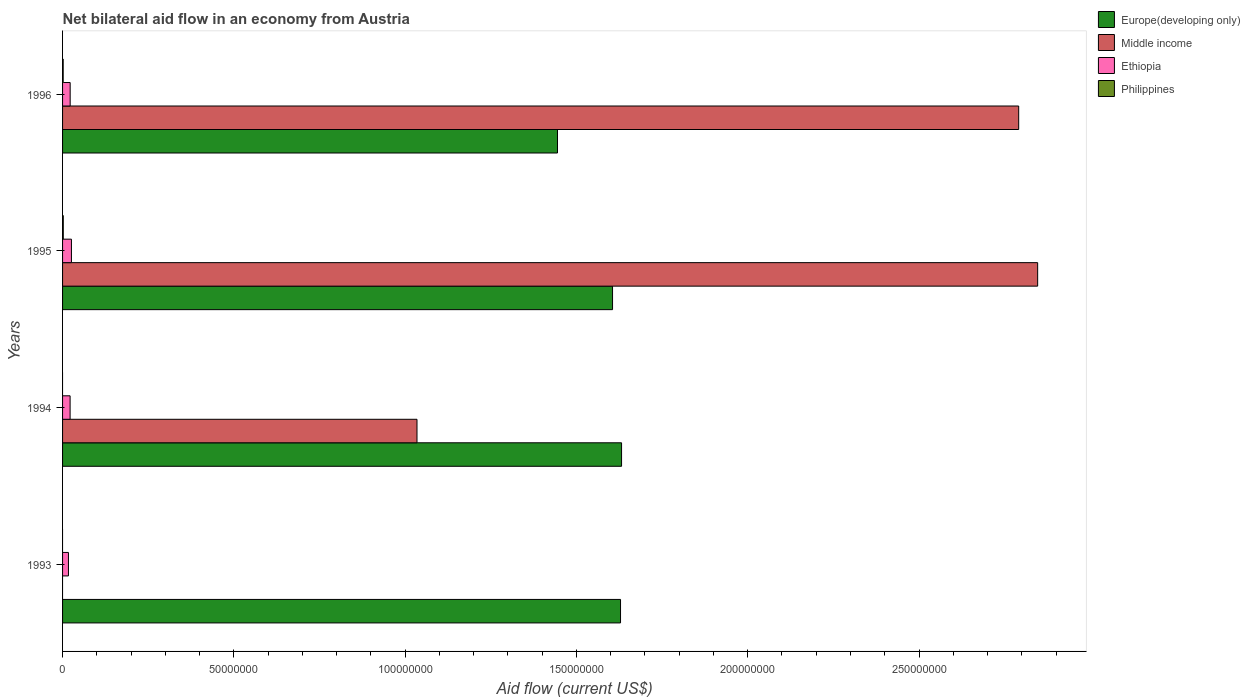How many groups of bars are there?
Make the answer very short. 4. Are the number of bars on each tick of the Y-axis equal?
Offer a terse response. No. How many bars are there on the 1st tick from the top?
Keep it short and to the point. 4. What is the label of the 4th group of bars from the top?
Your answer should be compact. 1993. In how many cases, is the number of bars for a given year not equal to the number of legend labels?
Offer a very short reply. 2. What is the net bilateral aid flow in Philippines in 1993?
Your response must be concise. 0. Across all years, what is the maximum net bilateral aid flow in Ethiopia?
Give a very brief answer. 2.59e+06. Across all years, what is the minimum net bilateral aid flow in Ethiopia?
Provide a short and direct response. 1.72e+06. What is the total net bilateral aid flow in Ethiopia in the graph?
Provide a short and direct response. 8.73e+06. What is the difference between the net bilateral aid flow in Ethiopia in 1993 and that in 1995?
Offer a very short reply. -8.70e+05. What is the difference between the net bilateral aid flow in Europe(developing only) in 1993 and the net bilateral aid flow in Ethiopia in 1995?
Provide a short and direct response. 1.60e+08. What is the average net bilateral aid flow in Middle income per year?
Provide a succinct answer. 1.67e+08. In the year 1996, what is the difference between the net bilateral aid flow in Europe(developing only) and net bilateral aid flow in Ethiopia?
Keep it short and to the point. 1.42e+08. In how many years, is the net bilateral aid flow in Philippines greater than 10000000 US$?
Make the answer very short. 0. What is the ratio of the net bilateral aid flow in Middle income in 1995 to that in 1996?
Give a very brief answer. 1.02. Is the net bilateral aid flow in Europe(developing only) in 1994 less than that in 1995?
Make the answer very short. No. What is the difference between the highest and the lowest net bilateral aid flow in Europe(developing only)?
Provide a short and direct response. 1.87e+07. Is the sum of the net bilateral aid flow in Europe(developing only) in 1994 and 1996 greater than the maximum net bilateral aid flow in Ethiopia across all years?
Give a very brief answer. Yes. Is it the case that in every year, the sum of the net bilateral aid flow in Middle income and net bilateral aid flow in Ethiopia is greater than the sum of net bilateral aid flow in Philippines and net bilateral aid flow in Europe(developing only)?
Your answer should be very brief. No. Is it the case that in every year, the sum of the net bilateral aid flow in Ethiopia and net bilateral aid flow in Europe(developing only) is greater than the net bilateral aid flow in Middle income?
Your response must be concise. No. How many bars are there?
Your answer should be compact. 13. Are all the bars in the graph horizontal?
Keep it short and to the point. Yes. How many years are there in the graph?
Offer a terse response. 4. Does the graph contain grids?
Keep it short and to the point. No. How are the legend labels stacked?
Provide a short and direct response. Vertical. What is the title of the graph?
Make the answer very short. Net bilateral aid flow in an economy from Austria. Does "Serbia" appear as one of the legend labels in the graph?
Provide a succinct answer. No. What is the Aid flow (current US$) of Europe(developing only) in 1993?
Your answer should be compact. 1.63e+08. What is the Aid flow (current US$) of Middle income in 1993?
Your response must be concise. 0. What is the Aid flow (current US$) in Ethiopia in 1993?
Your answer should be compact. 1.72e+06. What is the Aid flow (current US$) of Philippines in 1993?
Offer a terse response. 0. What is the Aid flow (current US$) of Europe(developing only) in 1994?
Ensure brevity in your answer.  1.63e+08. What is the Aid flow (current US$) in Middle income in 1994?
Give a very brief answer. 1.03e+08. What is the Aid flow (current US$) of Ethiopia in 1994?
Give a very brief answer. 2.20e+06. What is the Aid flow (current US$) of Philippines in 1994?
Give a very brief answer. 0. What is the Aid flow (current US$) in Europe(developing only) in 1995?
Provide a short and direct response. 1.61e+08. What is the Aid flow (current US$) of Middle income in 1995?
Make the answer very short. 2.85e+08. What is the Aid flow (current US$) in Ethiopia in 1995?
Your answer should be compact. 2.59e+06. What is the Aid flow (current US$) in Philippines in 1995?
Your answer should be very brief. 2.10e+05. What is the Aid flow (current US$) in Europe(developing only) in 1996?
Provide a short and direct response. 1.44e+08. What is the Aid flow (current US$) of Middle income in 1996?
Give a very brief answer. 2.79e+08. What is the Aid flow (current US$) in Ethiopia in 1996?
Provide a succinct answer. 2.22e+06. What is the Aid flow (current US$) of Philippines in 1996?
Give a very brief answer. 1.80e+05. Across all years, what is the maximum Aid flow (current US$) of Europe(developing only)?
Ensure brevity in your answer.  1.63e+08. Across all years, what is the maximum Aid flow (current US$) of Middle income?
Keep it short and to the point. 2.85e+08. Across all years, what is the maximum Aid flow (current US$) in Ethiopia?
Keep it short and to the point. 2.59e+06. Across all years, what is the minimum Aid flow (current US$) of Europe(developing only)?
Your answer should be compact. 1.44e+08. Across all years, what is the minimum Aid flow (current US$) of Middle income?
Your answer should be very brief. 0. Across all years, what is the minimum Aid flow (current US$) in Ethiopia?
Give a very brief answer. 1.72e+06. What is the total Aid flow (current US$) in Europe(developing only) in the graph?
Offer a very short reply. 6.31e+08. What is the total Aid flow (current US$) in Middle income in the graph?
Your answer should be compact. 6.67e+08. What is the total Aid flow (current US$) of Ethiopia in the graph?
Ensure brevity in your answer.  8.73e+06. What is the total Aid flow (current US$) of Philippines in the graph?
Your answer should be compact. 3.90e+05. What is the difference between the Aid flow (current US$) in Ethiopia in 1993 and that in 1994?
Keep it short and to the point. -4.80e+05. What is the difference between the Aid flow (current US$) of Europe(developing only) in 1993 and that in 1995?
Offer a very short reply. 2.33e+06. What is the difference between the Aid flow (current US$) of Ethiopia in 1993 and that in 1995?
Give a very brief answer. -8.70e+05. What is the difference between the Aid flow (current US$) of Europe(developing only) in 1993 and that in 1996?
Offer a very short reply. 1.84e+07. What is the difference between the Aid flow (current US$) in Ethiopia in 1993 and that in 1996?
Keep it short and to the point. -5.00e+05. What is the difference between the Aid flow (current US$) in Europe(developing only) in 1994 and that in 1995?
Your answer should be compact. 2.63e+06. What is the difference between the Aid flow (current US$) of Middle income in 1994 and that in 1995?
Keep it short and to the point. -1.81e+08. What is the difference between the Aid flow (current US$) in Ethiopia in 1994 and that in 1995?
Offer a terse response. -3.90e+05. What is the difference between the Aid flow (current US$) in Europe(developing only) in 1994 and that in 1996?
Ensure brevity in your answer.  1.87e+07. What is the difference between the Aid flow (current US$) in Middle income in 1994 and that in 1996?
Your response must be concise. -1.76e+08. What is the difference between the Aid flow (current US$) of Ethiopia in 1994 and that in 1996?
Give a very brief answer. -2.00e+04. What is the difference between the Aid flow (current US$) in Europe(developing only) in 1995 and that in 1996?
Your answer should be very brief. 1.61e+07. What is the difference between the Aid flow (current US$) in Middle income in 1995 and that in 1996?
Your answer should be very brief. 5.54e+06. What is the difference between the Aid flow (current US$) of Philippines in 1995 and that in 1996?
Offer a terse response. 3.00e+04. What is the difference between the Aid flow (current US$) of Europe(developing only) in 1993 and the Aid flow (current US$) of Middle income in 1994?
Your answer should be compact. 5.94e+07. What is the difference between the Aid flow (current US$) in Europe(developing only) in 1993 and the Aid flow (current US$) in Ethiopia in 1994?
Give a very brief answer. 1.61e+08. What is the difference between the Aid flow (current US$) of Europe(developing only) in 1993 and the Aid flow (current US$) of Middle income in 1995?
Give a very brief answer. -1.22e+08. What is the difference between the Aid flow (current US$) in Europe(developing only) in 1993 and the Aid flow (current US$) in Ethiopia in 1995?
Your response must be concise. 1.60e+08. What is the difference between the Aid flow (current US$) of Europe(developing only) in 1993 and the Aid flow (current US$) of Philippines in 1995?
Keep it short and to the point. 1.63e+08. What is the difference between the Aid flow (current US$) of Ethiopia in 1993 and the Aid flow (current US$) of Philippines in 1995?
Provide a succinct answer. 1.51e+06. What is the difference between the Aid flow (current US$) of Europe(developing only) in 1993 and the Aid flow (current US$) of Middle income in 1996?
Your answer should be compact. -1.16e+08. What is the difference between the Aid flow (current US$) of Europe(developing only) in 1993 and the Aid flow (current US$) of Ethiopia in 1996?
Provide a succinct answer. 1.61e+08. What is the difference between the Aid flow (current US$) in Europe(developing only) in 1993 and the Aid flow (current US$) in Philippines in 1996?
Provide a succinct answer. 1.63e+08. What is the difference between the Aid flow (current US$) in Ethiopia in 1993 and the Aid flow (current US$) in Philippines in 1996?
Offer a very short reply. 1.54e+06. What is the difference between the Aid flow (current US$) of Europe(developing only) in 1994 and the Aid flow (current US$) of Middle income in 1995?
Keep it short and to the point. -1.21e+08. What is the difference between the Aid flow (current US$) of Europe(developing only) in 1994 and the Aid flow (current US$) of Ethiopia in 1995?
Offer a terse response. 1.61e+08. What is the difference between the Aid flow (current US$) in Europe(developing only) in 1994 and the Aid flow (current US$) in Philippines in 1995?
Offer a very short reply. 1.63e+08. What is the difference between the Aid flow (current US$) of Middle income in 1994 and the Aid flow (current US$) of Ethiopia in 1995?
Offer a very short reply. 1.01e+08. What is the difference between the Aid flow (current US$) in Middle income in 1994 and the Aid flow (current US$) in Philippines in 1995?
Your answer should be very brief. 1.03e+08. What is the difference between the Aid flow (current US$) in Ethiopia in 1994 and the Aid flow (current US$) in Philippines in 1995?
Provide a short and direct response. 1.99e+06. What is the difference between the Aid flow (current US$) of Europe(developing only) in 1994 and the Aid flow (current US$) of Middle income in 1996?
Provide a short and direct response. -1.16e+08. What is the difference between the Aid flow (current US$) in Europe(developing only) in 1994 and the Aid flow (current US$) in Ethiopia in 1996?
Offer a terse response. 1.61e+08. What is the difference between the Aid flow (current US$) of Europe(developing only) in 1994 and the Aid flow (current US$) of Philippines in 1996?
Provide a succinct answer. 1.63e+08. What is the difference between the Aid flow (current US$) of Middle income in 1994 and the Aid flow (current US$) of Ethiopia in 1996?
Your answer should be compact. 1.01e+08. What is the difference between the Aid flow (current US$) in Middle income in 1994 and the Aid flow (current US$) in Philippines in 1996?
Ensure brevity in your answer.  1.03e+08. What is the difference between the Aid flow (current US$) of Ethiopia in 1994 and the Aid flow (current US$) of Philippines in 1996?
Ensure brevity in your answer.  2.02e+06. What is the difference between the Aid flow (current US$) of Europe(developing only) in 1995 and the Aid flow (current US$) of Middle income in 1996?
Your response must be concise. -1.19e+08. What is the difference between the Aid flow (current US$) in Europe(developing only) in 1995 and the Aid flow (current US$) in Ethiopia in 1996?
Give a very brief answer. 1.58e+08. What is the difference between the Aid flow (current US$) of Europe(developing only) in 1995 and the Aid flow (current US$) of Philippines in 1996?
Your answer should be very brief. 1.60e+08. What is the difference between the Aid flow (current US$) of Middle income in 1995 and the Aid flow (current US$) of Ethiopia in 1996?
Give a very brief answer. 2.82e+08. What is the difference between the Aid flow (current US$) of Middle income in 1995 and the Aid flow (current US$) of Philippines in 1996?
Give a very brief answer. 2.84e+08. What is the difference between the Aid flow (current US$) of Ethiopia in 1995 and the Aid flow (current US$) of Philippines in 1996?
Keep it short and to the point. 2.41e+06. What is the average Aid flow (current US$) of Europe(developing only) per year?
Your answer should be compact. 1.58e+08. What is the average Aid flow (current US$) in Middle income per year?
Provide a succinct answer. 1.67e+08. What is the average Aid flow (current US$) in Ethiopia per year?
Your answer should be very brief. 2.18e+06. What is the average Aid flow (current US$) in Philippines per year?
Your response must be concise. 9.75e+04. In the year 1993, what is the difference between the Aid flow (current US$) in Europe(developing only) and Aid flow (current US$) in Ethiopia?
Provide a succinct answer. 1.61e+08. In the year 1994, what is the difference between the Aid flow (current US$) of Europe(developing only) and Aid flow (current US$) of Middle income?
Keep it short and to the point. 5.97e+07. In the year 1994, what is the difference between the Aid flow (current US$) in Europe(developing only) and Aid flow (current US$) in Ethiopia?
Keep it short and to the point. 1.61e+08. In the year 1994, what is the difference between the Aid flow (current US$) in Middle income and Aid flow (current US$) in Ethiopia?
Provide a succinct answer. 1.01e+08. In the year 1995, what is the difference between the Aid flow (current US$) in Europe(developing only) and Aid flow (current US$) in Middle income?
Give a very brief answer. -1.24e+08. In the year 1995, what is the difference between the Aid flow (current US$) in Europe(developing only) and Aid flow (current US$) in Ethiopia?
Your response must be concise. 1.58e+08. In the year 1995, what is the difference between the Aid flow (current US$) in Europe(developing only) and Aid flow (current US$) in Philippines?
Your answer should be very brief. 1.60e+08. In the year 1995, what is the difference between the Aid flow (current US$) in Middle income and Aid flow (current US$) in Ethiopia?
Ensure brevity in your answer.  2.82e+08. In the year 1995, what is the difference between the Aid flow (current US$) of Middle income and Aid flow (current US$) of Philippines?
Provide a succinct answer. 2.84e+08. In the year 1995, what is the difference between the Aid flow (current US$) of Ethiopia and Aid flow (current US$) of Philippines?
Offer a terse response. 2.38e+06. In the year 1996, what is the difference between the Aid flow (current US$) of Europe(developing only) and Aid flow (current US$) of Middle income?
Your answer should be very brief. -1.35e+08. In the year 1996, what is the difference between the Aid flow (current US$) in Europe(developing only) and Aid flow (current US$) in Ethiopia?
Your answer should be very brief. 1.42e+08. In the year 1996, what is the difference between the Aid flow (current US$) in Europe(developing only) and Aid flow (current US$) in Philippines?
Give a very brief answer. 1.44e+08. In the year 1996, what is the difference between the Aid flow (current US$) of Middle income and Aid flow (current US$) of Ethiopia?
Your answer should be very brief. 2.77e+08. In the year 1996, what is the difference between the Aid flow (current US$) in Middle income and Aid flow (current US$) in Philippines?
Your answer should be very brief. 2.79e+08. In the year 1996, what is the difference between the Aid flow (current US$) of Ethiopia and Aid flow (current US$) of Philippines?
Keep it short and to the point. 2.04e+06. What is the ratio of the Aid flow (current US$) of Europe(developing only) in 1993 to that in 1994?
Make the answer very short. 1. What is the ratio of the Aid flow (current US$) in Ethiopia in 1993 to that in 1994?
Your answer should be very brief. 0.78. What is the ratio of the Aid flow (current US$) of Europe(developing only) in 1993 to that in 1995?
Your response must be concise. 1.01. What is the ratio of the Aid flow (current US$) of Ethiopia in 1993 to that in 1995?
Provide a short and direct response. 0.66. What is the ratio of the Aid flow (current US$) in Europe(developing only) in 1993 to that in 1996?
Your answer should be compact. 1.13. What is the ratio of the Aid flow (current US$) in Ethiopia in 1993 to that in 1996?
Your answer should be very brief. 0.77. What is the ratio of the Aid flow (current US$) in Europe(developing only) in 1994 to that in 1995?
Your answer should be compact. 1.02. What is the ratio of the Aid flow (current US$) in Middle income in 1994 to that in 1995?
Provide a short and direct response. 0.36. What is the ratio of the Aid flow (current US$) in Ethiopia in 1994 to that in 1995?
Provide a short and direct response. 0.85. What is the ratio of the Aid flow (current US$) in Europe(developing only) in 1994 to that in 1996?
Your answer should be compact. 1.13. What is the ratio of the Aid flow (current US$) of Middle income in 1994 to that in 1996?
Your answer should be very brief. 0.37. What is the ratio of the Aid flow (current US$) in Ethiopia in 1994 to that in 1996?
Your answer should be very brief. 0.99. What is the ratio of the Aid flow (current US$) of Europe(developing only) in 1995 to that in 1996?
Give a very brief answer. 1.11. What is the ratio of the Aid flow (current US$) in Middle income in 1995 to that in 1996?
Your answer should be very brief. 1.02. What is the difference between the highest and the second highest Aid flow (current US$) of Europe(developing only)?
Give a very brief answer. 3.00e+05. What is the difference between the highest and the second highest Aid flow (current US$) of Middle income?
Provide a short and direct response. 5.54e+06. What is the difference between the highest and the lowest Aid flow (current US$) of Europe(developing only)?
Offer a terse response. 1.87e+07. What is the difference between the highest and the lowest Aid flow (current US$) in Middle income?
Provide a succinct answer. 2.85e+08. What is the difference between the highest and the lowest Aid flow (current US$) in Ethiopia?
Ensure brevity in your answer.  8.70e+05. What is the difference between the highest and the lowest Aid flow (current US$) in Philippines?
Offer a very short reply. 2.10e+05. 